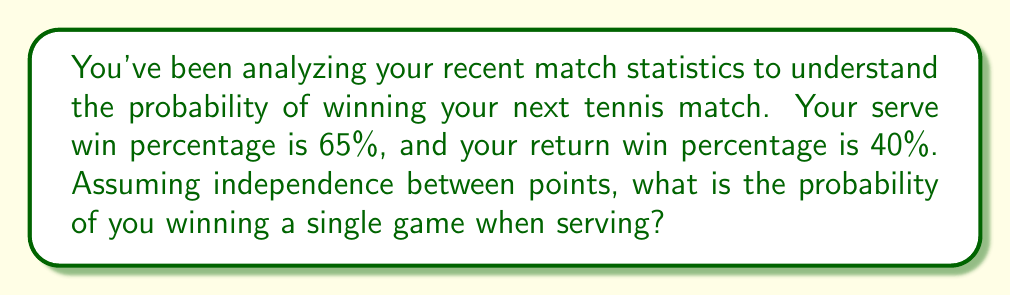Give your solution to this math problem. Let's approach this step-by-step:

1) In a tennis game, you need to win 4 points to win the game. However, if the score reaches deuce (3-3), you need to win by 2 clear points.

2) The probability of winning a game can be modeled using a Markov chain. Let $p$ be the probability of winning a point when serving.

3) The probability of winning a game without reaching deuce is:

   $$P(\text{win without deuce}) = p^4 + 4p^4(1-p) + 10p^4(1-p)^2 + 20p^4(1-p)^3$$

4) The probability of reaching deuce is:

   $$P(\text{reach deuce}) = 20p^3(1-p)^3$$

5) Once at deuce, the probability of winning is:

   $$P(\text{win from deuce}) = \frac{p^2}{p^2 + (1-p)^2}$$

6) Therefore, the total probability of winning a game when serving is:

   $$P(\text{win game}) = P(\text{win without deuce}) + P(\text{reach deuce}) \cdot P(\text{win from deuce})$$

7) Substituting $p = 0.65$ (65% serve win percentage) into these formulas:

   $$P(\text{win without deuce}) = 0.65^4 + 4(0.65^4)(0.35) + 10(0.65^4)(0.35^2) + 20(0.65^4)(0.35^3) = 0.7351$$

   $$P(\text{reach deuce}) = 20(0.65^3)(0.35^3) = 0.2276$$

   $$P(\text{win from deuce}) = \frac{0.65^2}{0.65^2 + 0.35^2} = 0.7757$$

8) Finally:

   $$P(\text{win game}) = 0.7351 + 0.2276 \cdot 0.7757 = 0.9116$$

Therefore, the probability of winning a single game when serving is approximately 0.9116 or 91.16%.
Answer: 0.9116 